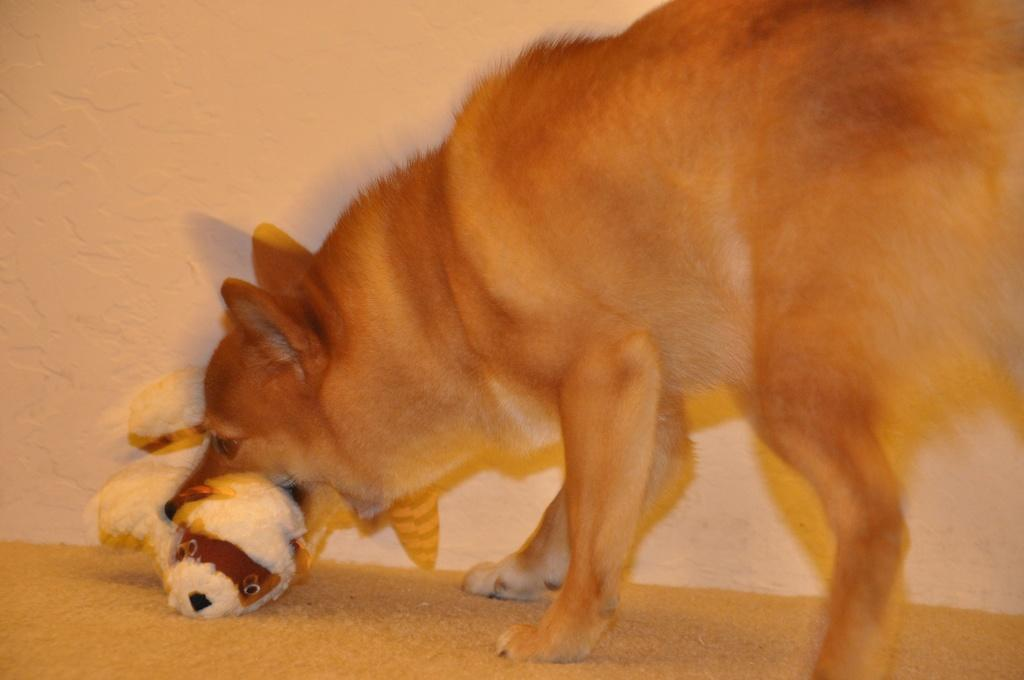What animal is present in the image? There is a dog in the image. What is the dog doing with its mouth? The dog is holding a toy in its mouth. Where is the toy located in relation to the dog? The toy is on the floor. How many cows are visible in the image? There are no cows present in the image; it features a dog holding a toy. Who is the owner of the dog in the image? The image does not provide information about the dog's owner. 